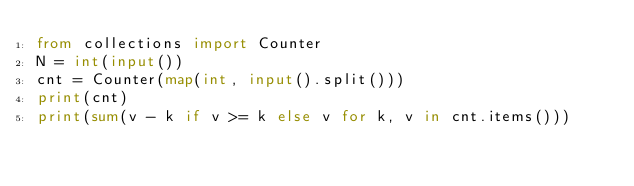<code> <loc_0><loc_0><loc_500><loc_500><_Python_>from collections import Counter
N = int(input())
cnt = Counter(map(int, input().split()))
print(cnt)
print(sum(v - k if v >= k else v for k, v in cnt.items()))</code> 